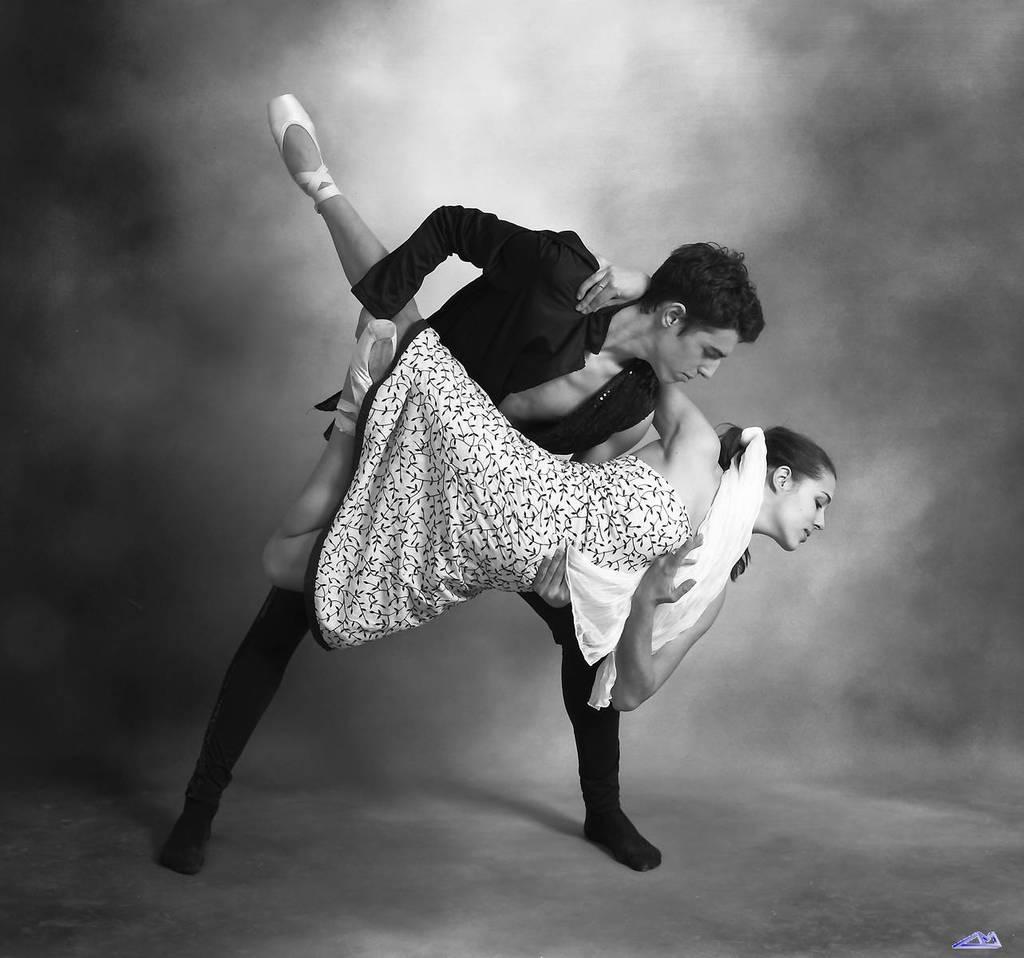Can you describe this image briefly? This is a black and white image and here we can see a man holding a woman and in the background, there is smoke. At the bottom, there is a logo. 